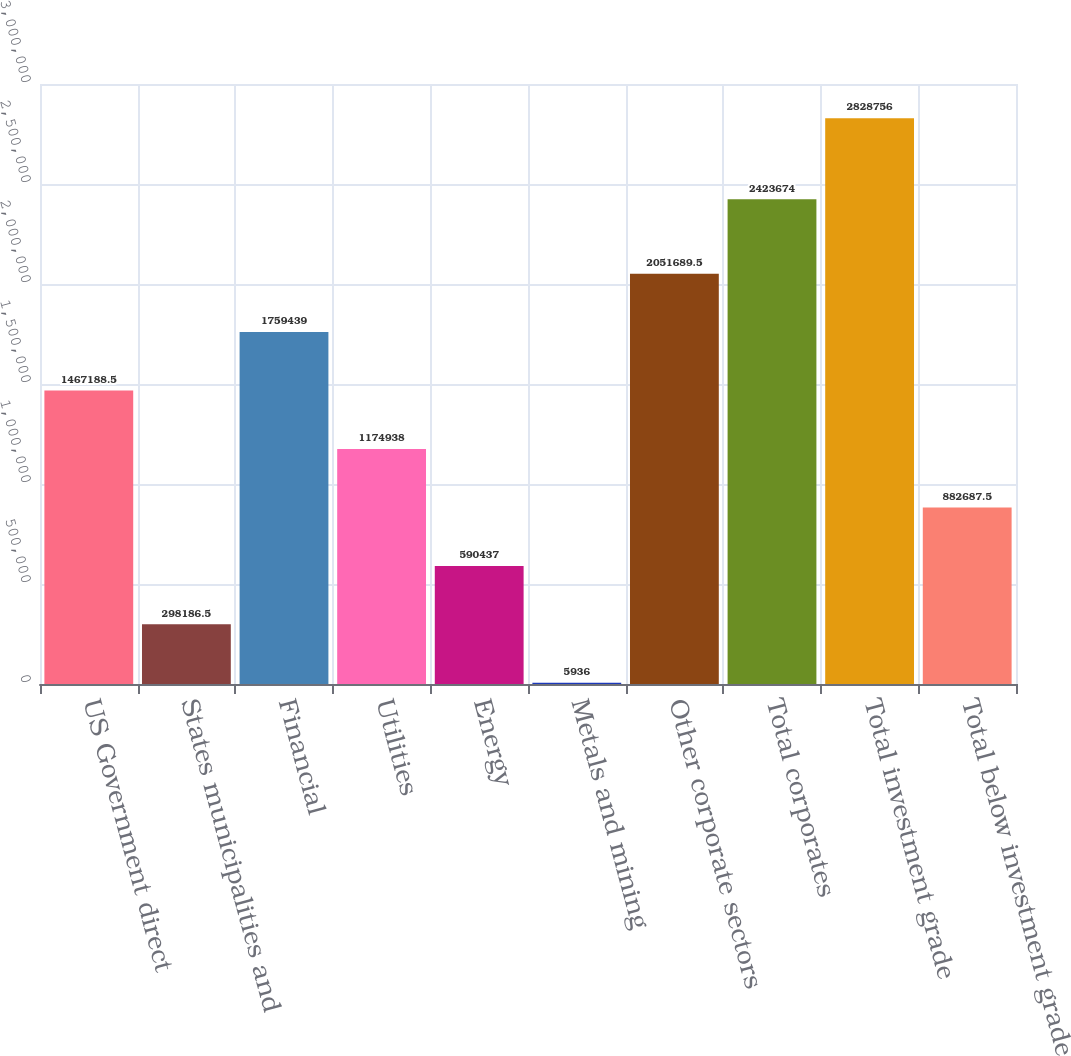Convert chart. <chart><loc_0><loc_0><loc_500><loc_500><bar_chart><fcel>US Government direct<fcel>States municipalities and<fcel>Financial<fcel>Utilities<fcel>Energy<fcel>Metals and mining<fcel>Other corporate sectors<fcel>Total corporates<fcel>Total investment grade<fcel>Total below investment grade<nl><fcel>1.46719e+06<fcel>298186<fcel>1.75944e+06<fcel>1.17494e+06<fcel>590437<fcel>5936<fcel>2.05169e+06<fcel>2.42367e+06<fcel>2.82876e+06<fcel>882688<nl></chart> 